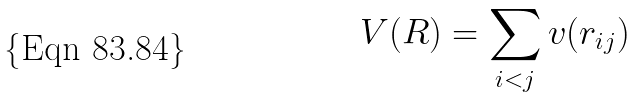Convert formula to latex. <formula><loc_0><loc_0><loc_500><loc_500>V ( R ) = \sum _ { i < j } v ( r _ { i j } )</formula> 